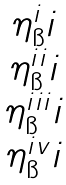<formula> <loc_0><loc_0><loc_500><loc_500>\begin{matrix} \eta ^ { i } _ { \i } i \\ \eta ^ { i i } _ { \i } i \\ \eta ^ { i i i } _ { \i } i \\ \eta ^ { i v } _ { \i } i \end{matrix}</formula> 